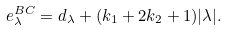Convert formula to latex. <formula><loc_0><loc_0><loc_500><loc_500>e ^ { B C } _ { \lambda } = d _ { \lambda } + ( k _ { 1 } + 2 k _ { 2 } + 1 ) | \lambda | .</formula> 